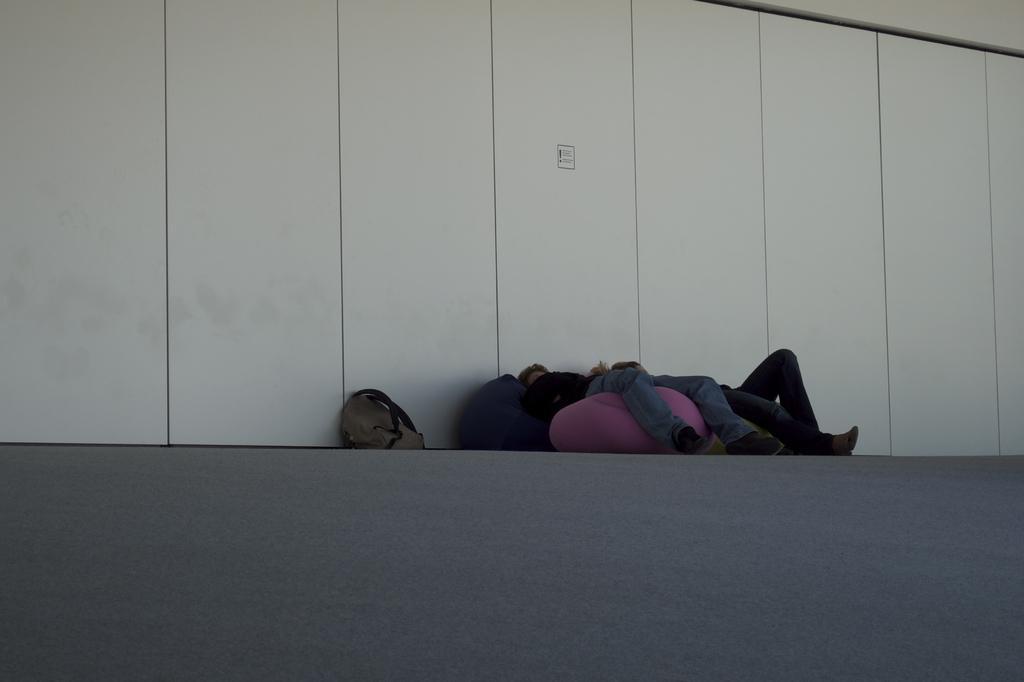Could you give a brief overview of what you see in this image? There is a bag, it seems like people laying in the foreground area of the image, it seems like a wall in the background area. 